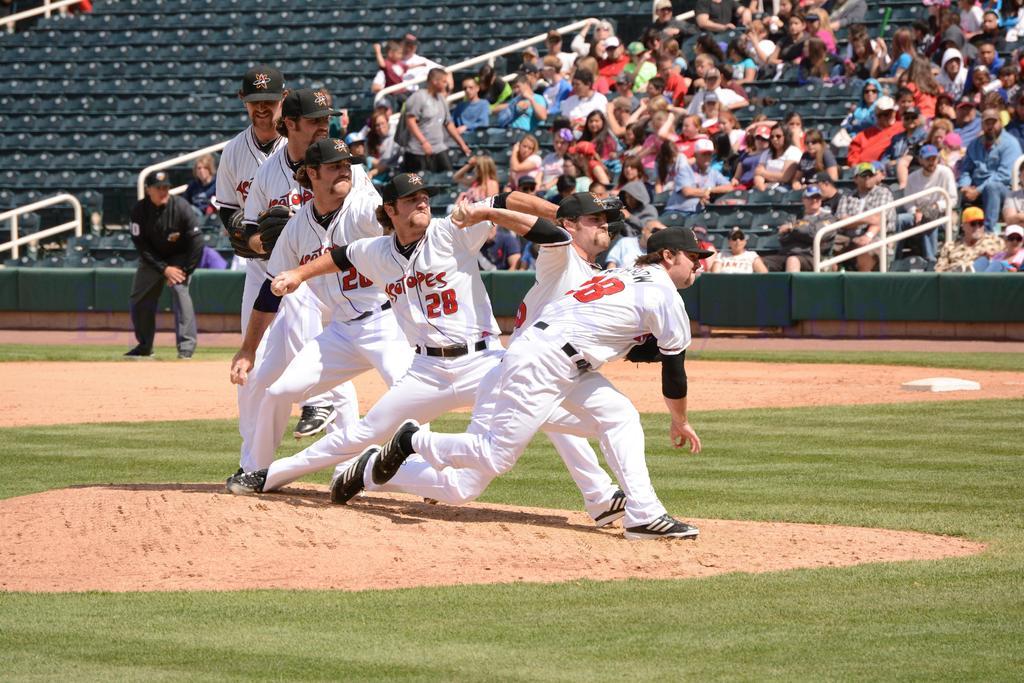What number is the pitcher?
Your response must be concise. 28. 